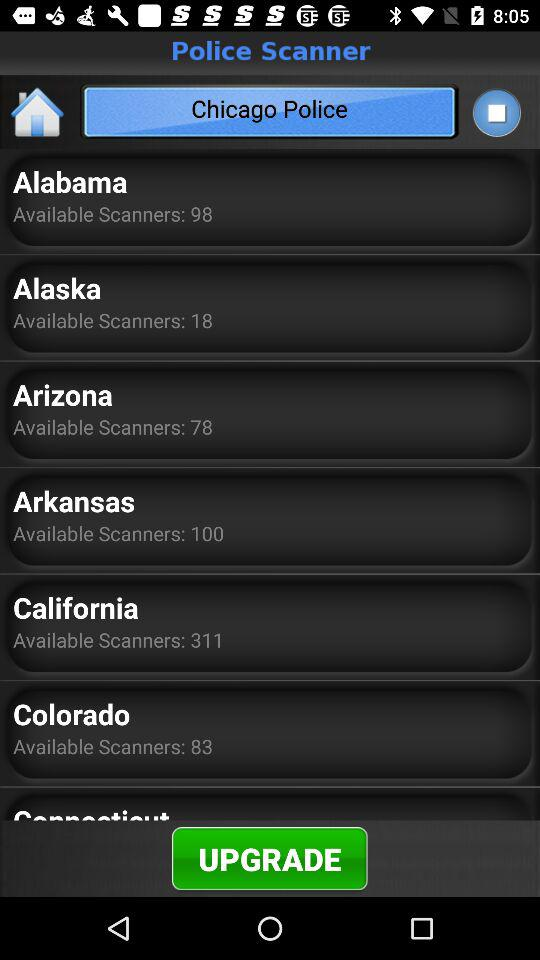What is the number of scanners in Arizona? The number of scanners in Arizona is 78. 